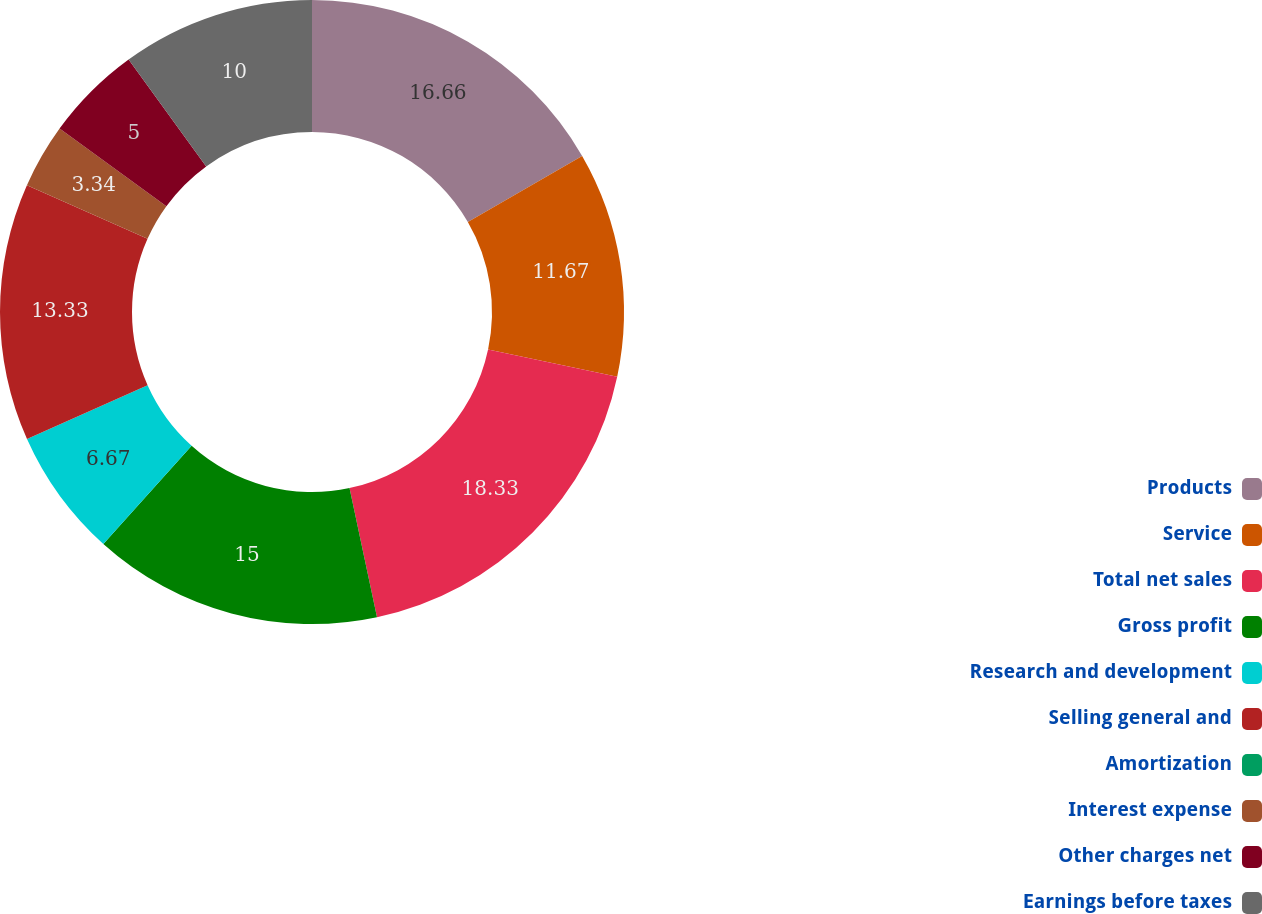Convert chart to OTSL. <chart><loc_0><loc_0><loc_500><loc_500><pie_chart><fcel>Products<fcel>Service<fcel>Total net sales<fcel>Gross profit<fcel>Research and development<fcel>Selling general and<fcel>Amortization<fcel>Interest expense<fcel>Other charges net<fcel>Earnings before taxes<nl><fcel>16.66%<fcel>11.67%<fcel>18.33%<fcel>15.0%<fcel>6.67%<fcel>13.33%<fcel>0.0%<fcel>3.34%<fcel>5.0%<fcel>10.0%<nl></chart> 